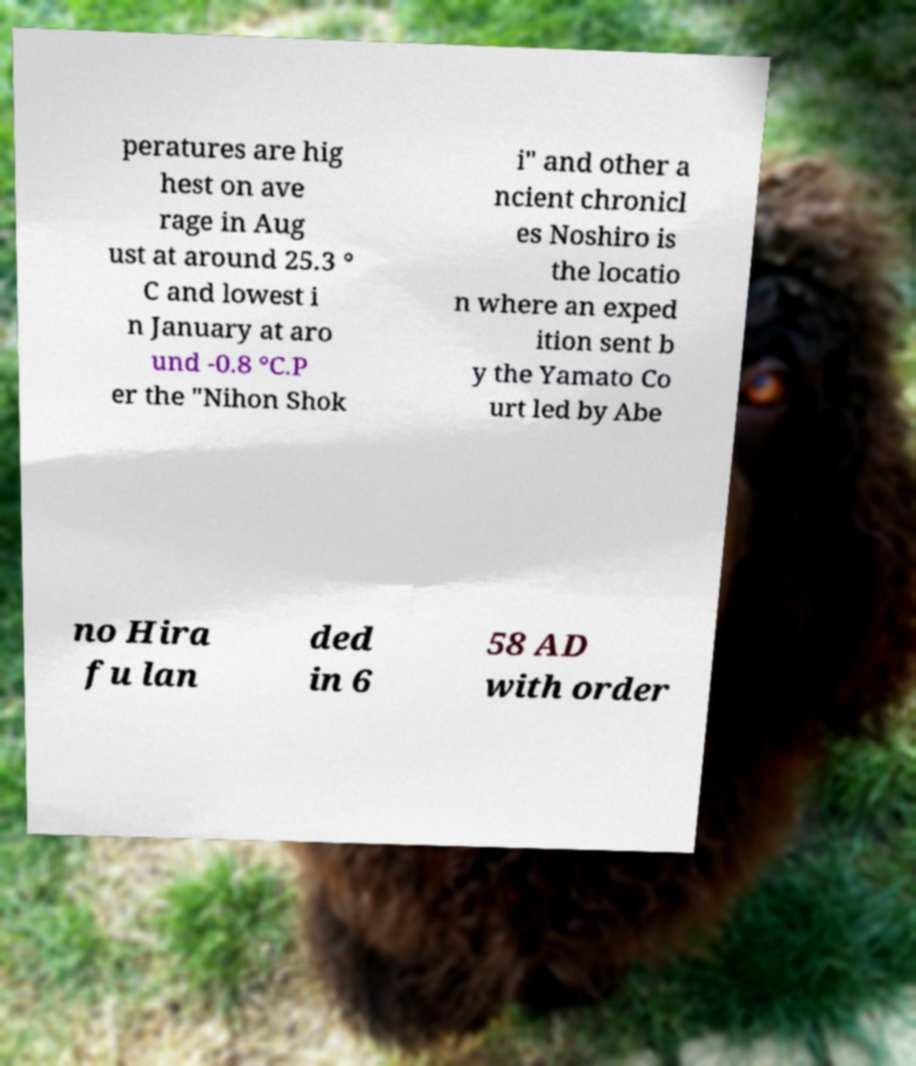Please read and relay the text visible in this image. What does it say? peratures are hig hest on ave rage in Aug ust at around 25.3 ° C and lowest i n January at aro und -0.8 °C.P er the "Nihon Shok i" and other a ncient chronicl es Noshiro is the locatio n where an exped ition sent b y the Yamato Co urt led by Abe no Hira fu lan ded in 6 58 AD with order 